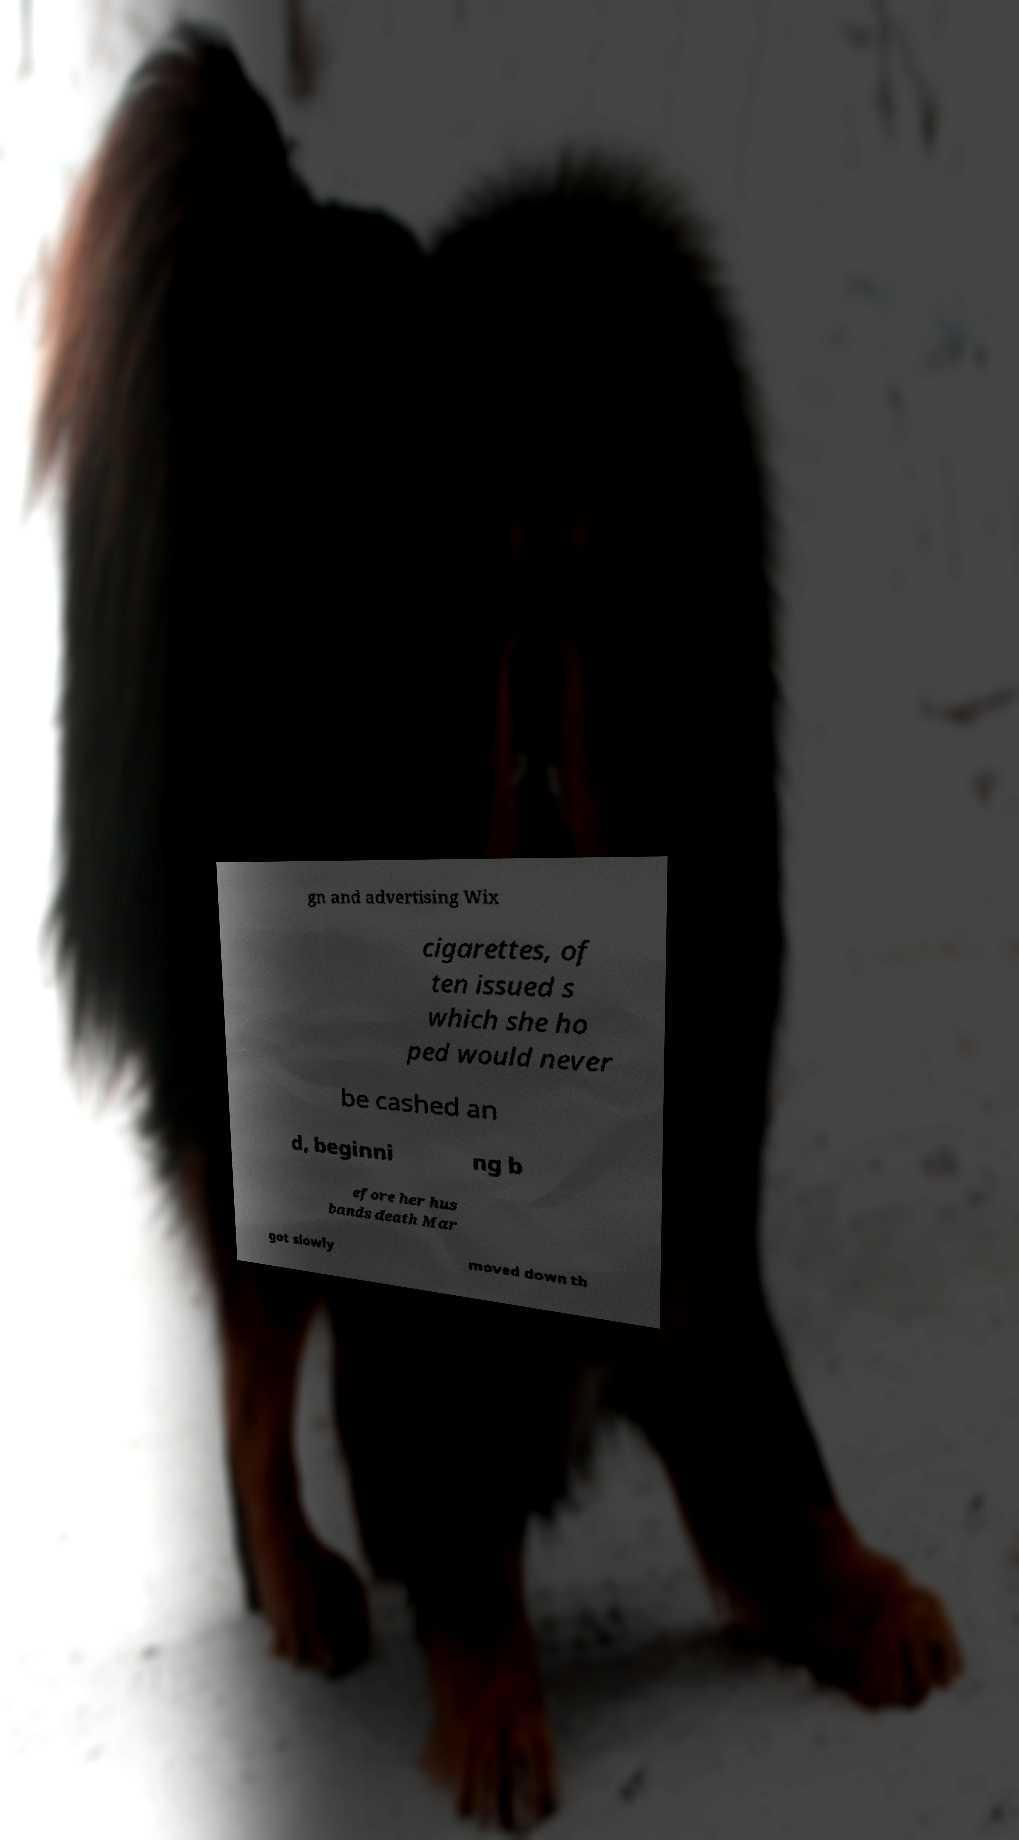For documentation purposes, I need the text within this image transcribed. Could you provide that? gn and advertising Wix cigarettes, of ten issued s which she ho ped would never be cashed an d, beginni ng b efore her hus bands death Mar got slowly moved down th 